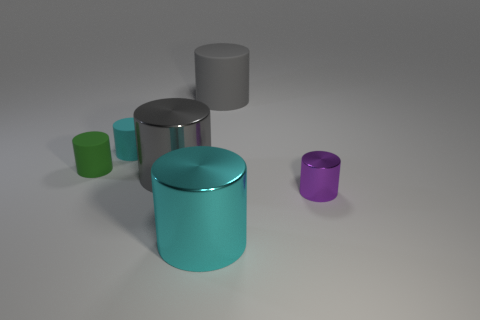Is there any indication of the size of these objects? In the absence of a reference object for scale, it's challenging to accurately gauge the size of the objects, but they seem to be of a size that could comfortably sit on a household table or desk. 